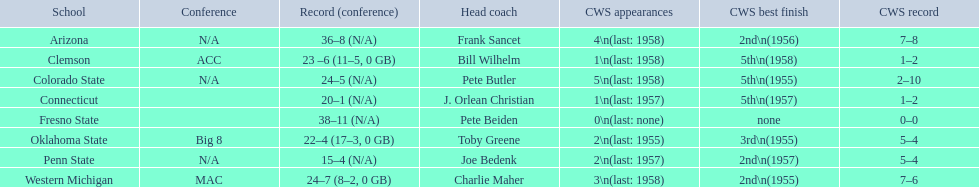What was the lowest number of wins achieved by the team with the most losses? 15–4 (N/A). Which team maintained this record? Penn State. 